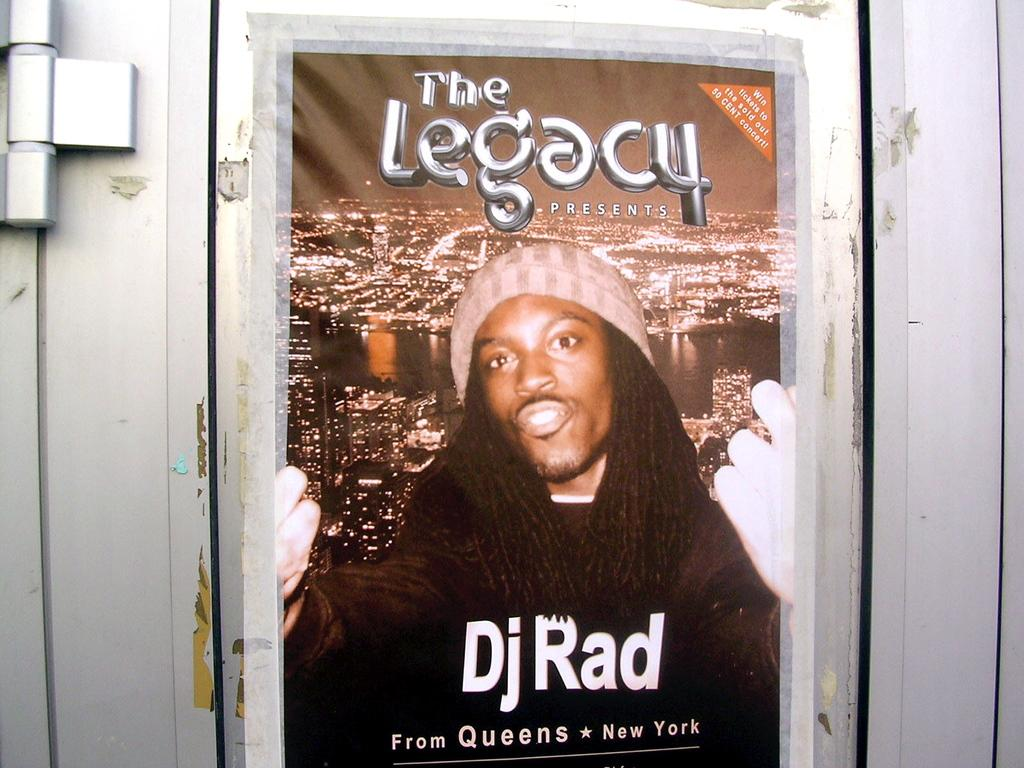What is on the wall in the image? There is a poster on the wall in the image. What is depicted on the poster? The poster contains an image of a person. What else is present on the poster besides the image? The poster contains text. What type of prison is visible in the image? There is no prison present in the image; it only features a poster with an image of a person and text. 